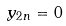Convert formula to latex. <formula><loc_0><loc_0><loc_500><loc_500>y _ { 2 n } = 0</formula> 